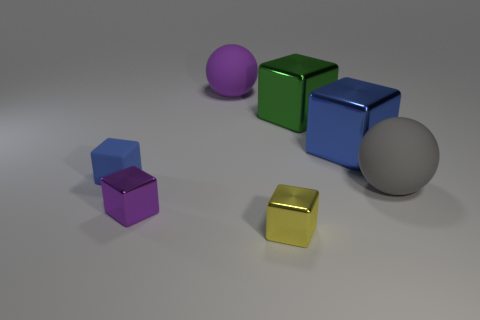Which object stands out the most and why? The small gold or yellowish cube stands out due to its bright, reflective surface and distinct color, which offers a strong contrast to the muted colors and matte finishes of the other objects. If you had to guess, what material could that golden cube be made from? Based on its reflective surface and golden hue, it could represent a metallic object, perhaps implying it is made of a material like gold, brass, or a similarly colored alloy. 